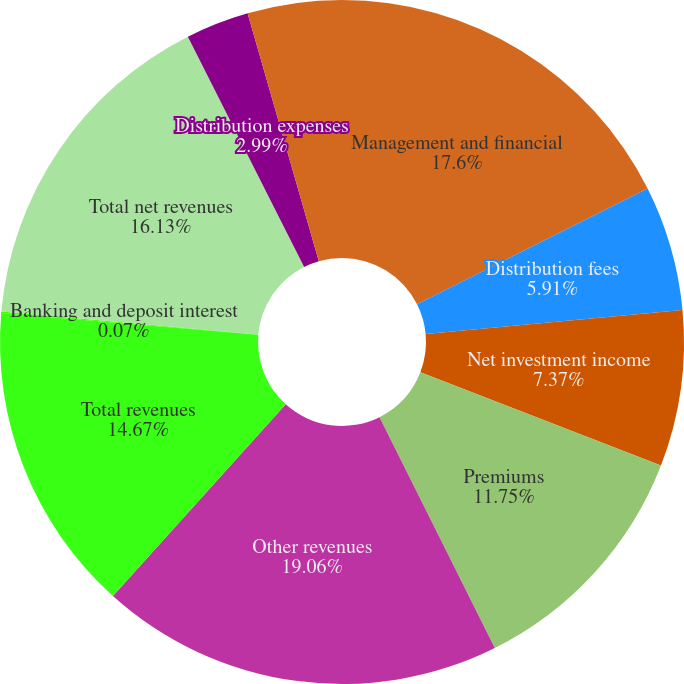<chart> <loc_0><loc_0><loc_500><loc_500><pie_chart><fcel>Management and financial<fcel>Distribution fees<fcel>Net investment income<fcel>Premiums<fcel>Other revenues<fcel>Total revenues<fcel>Banking and deposit interest<fcel>Total net revenues<fcel>Distribution expenses<fcel>Interest credited to fixed<nl><fcel>17.59%<fcel>5.91%<fcel>7.37%<fcel>11.75%<fcel>19.05%<fcel>14.67%<fcel>0.07%<fcel>16.13%<fcel>2.99%<fcel>4.45%<nl></chart> 